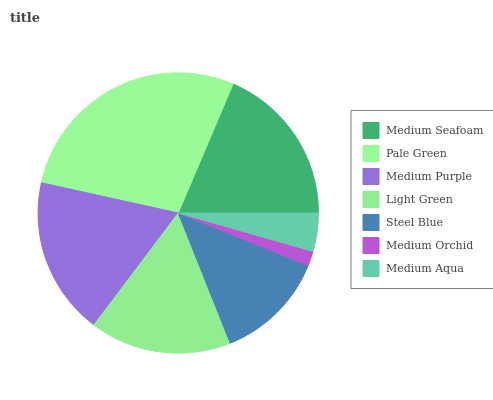Is Medium Orchid the minimum?
Answer yes or no. Yes. Is Pale Green the maximum?
Answer yes or no. Yes. Is Medium Purple the minimum?
Answer yes or no. No. Is Medium Purple the maximum?
Answer yes or no. No. Is Pale Green greater than Medium Purple?
Answer yes or no. Yes. Is Medium Purple less than Pale Green?
Answer yes or no. Yes. Is Medium Purple greater than Pale Green?
Answer yes or no. No. Is Pale Green less than Medium Purple?
Answer yes or no. No. Is Light Green the high median?
Answer yes or no. Yes. Is Light Green the low median?
Answer yes or no. Yes. Is Medium Seafoam the high median?
Answer yes or no. No. Is Medium Aqua the low median?
Answer yes or no. No. 